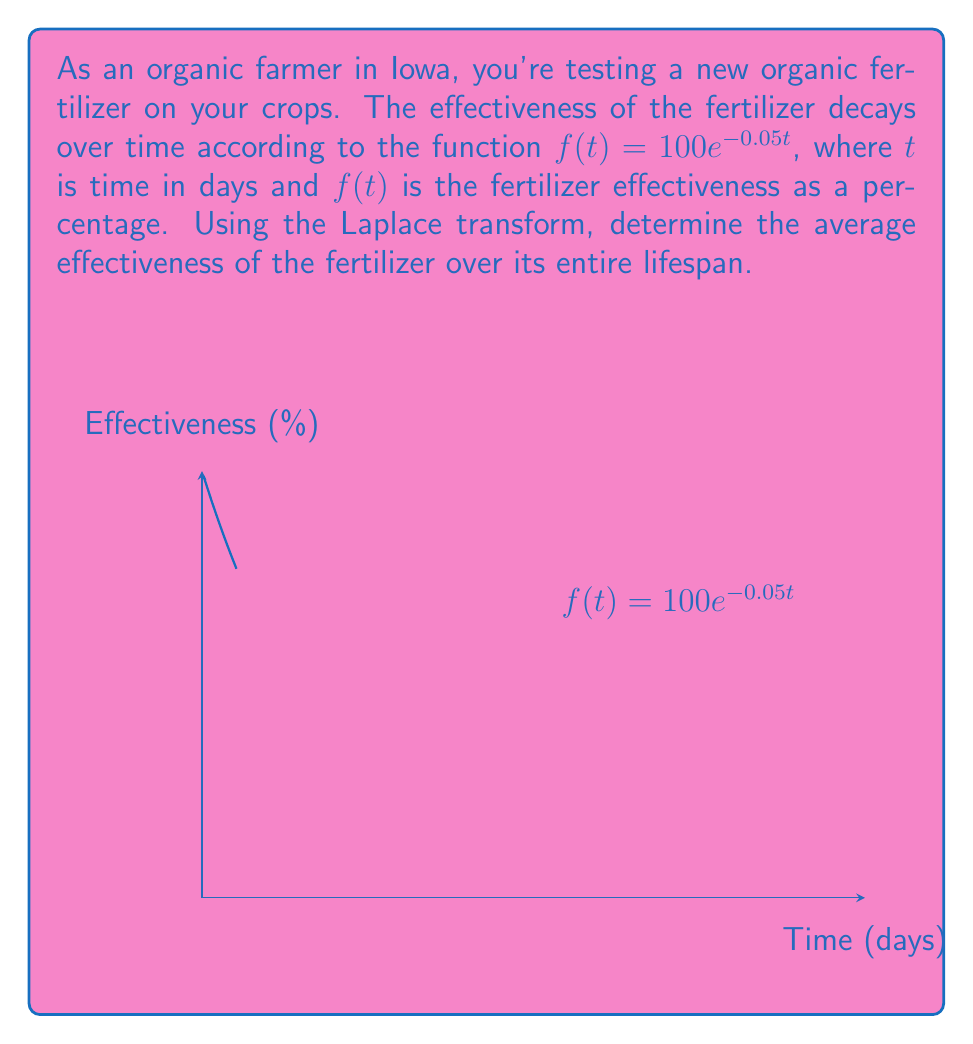Show me your answer to this math problem. Let's approach this step-by-step:

1) The Laplace transform of $f(t)$ is given by:
   $$F(s) = \mathcal{L}\{f(t)\} = \int_0^\infty f(t)e^{-st} dt$$

2) For our function $f(t) = 100e^{-0.05t}$, we have:
   $$F(s) = 100 \int_0^\infty e^{-0.05t}e^{-st} dt = 100 \int_0^\infty e^{-(s+0.05)t} dt$$

3) Solving this integral:
   $$F(s) = 100 \left[-\frac{1}{s+0.05}e^{-(s+0.05)t}\right]_0^\infty = \frac{100}{s+0.05}$$

4) The average value of a function over its entire lifespan is given by:
   $$\lim_{s \to 0} sF(s)$$

5) Applying this to our Laplace transform:
   $$\lim_{s \to 0} s\frac{100}{s+0.05} = \lim_{s \to 0} \frac{100s}{s+0.05}$$

6) Using L'Hôpital's rule:
   $$\lim_{s \to 0} \frac{100s}{s+0.05} = \lim_{s \to 0} \frac{100}{1} = 100$$

7) Therefore, the average effectiveness of the fertilizer over its entire lifespan is 100%.
Answer: 100% 